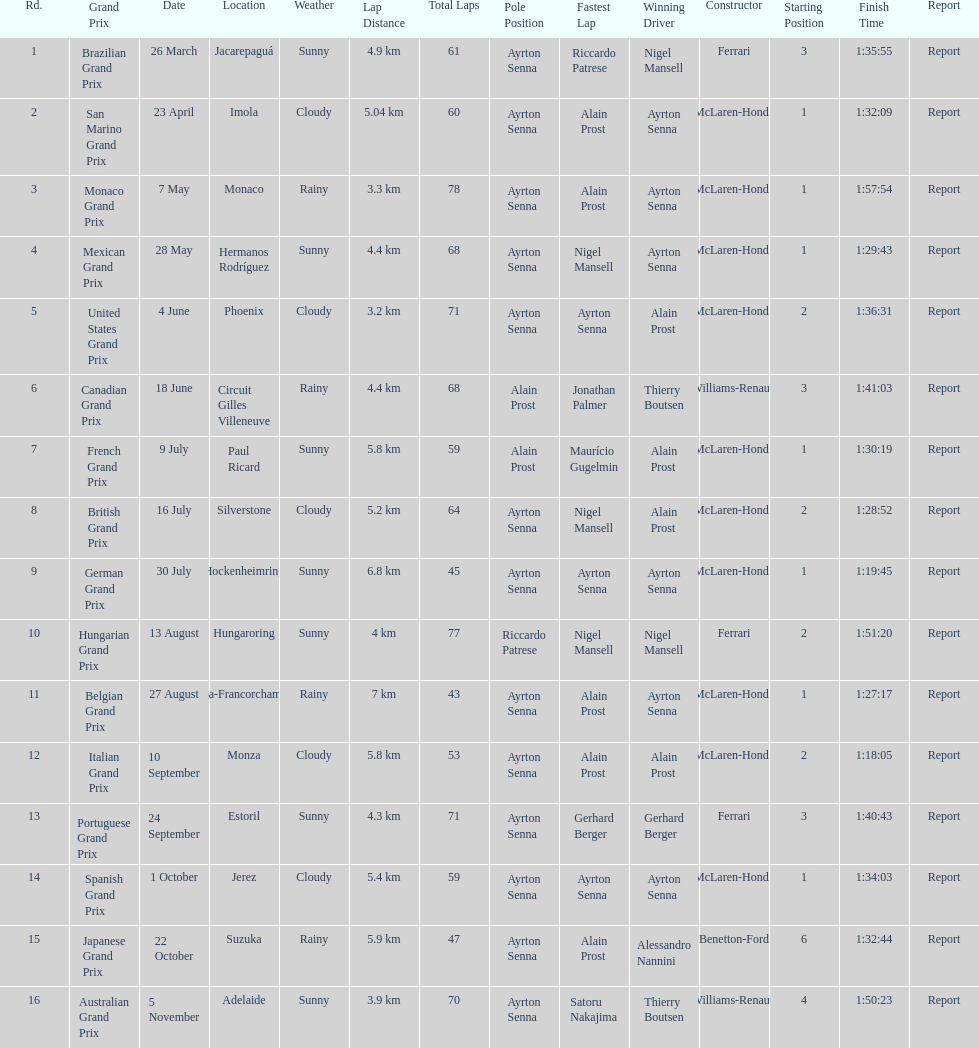Who are the constructors in the 1989 formula one season? Ferrari, McLaren-Honda, McLaren-Honda, McLaren-Honda, McLaren-Honda, Williams-Renault, McLaren-Honda, McLaren-Honda, McLaren-Honda, Ferrari, McLaren-Honda, McLaren-Honda, Ferrari, McLaren-Honda, Benetton-Ford, Williams-Renault. On what date was bennington ford the constructor? 22 October. What was the race on october 22? Japanese Grand Prix. 